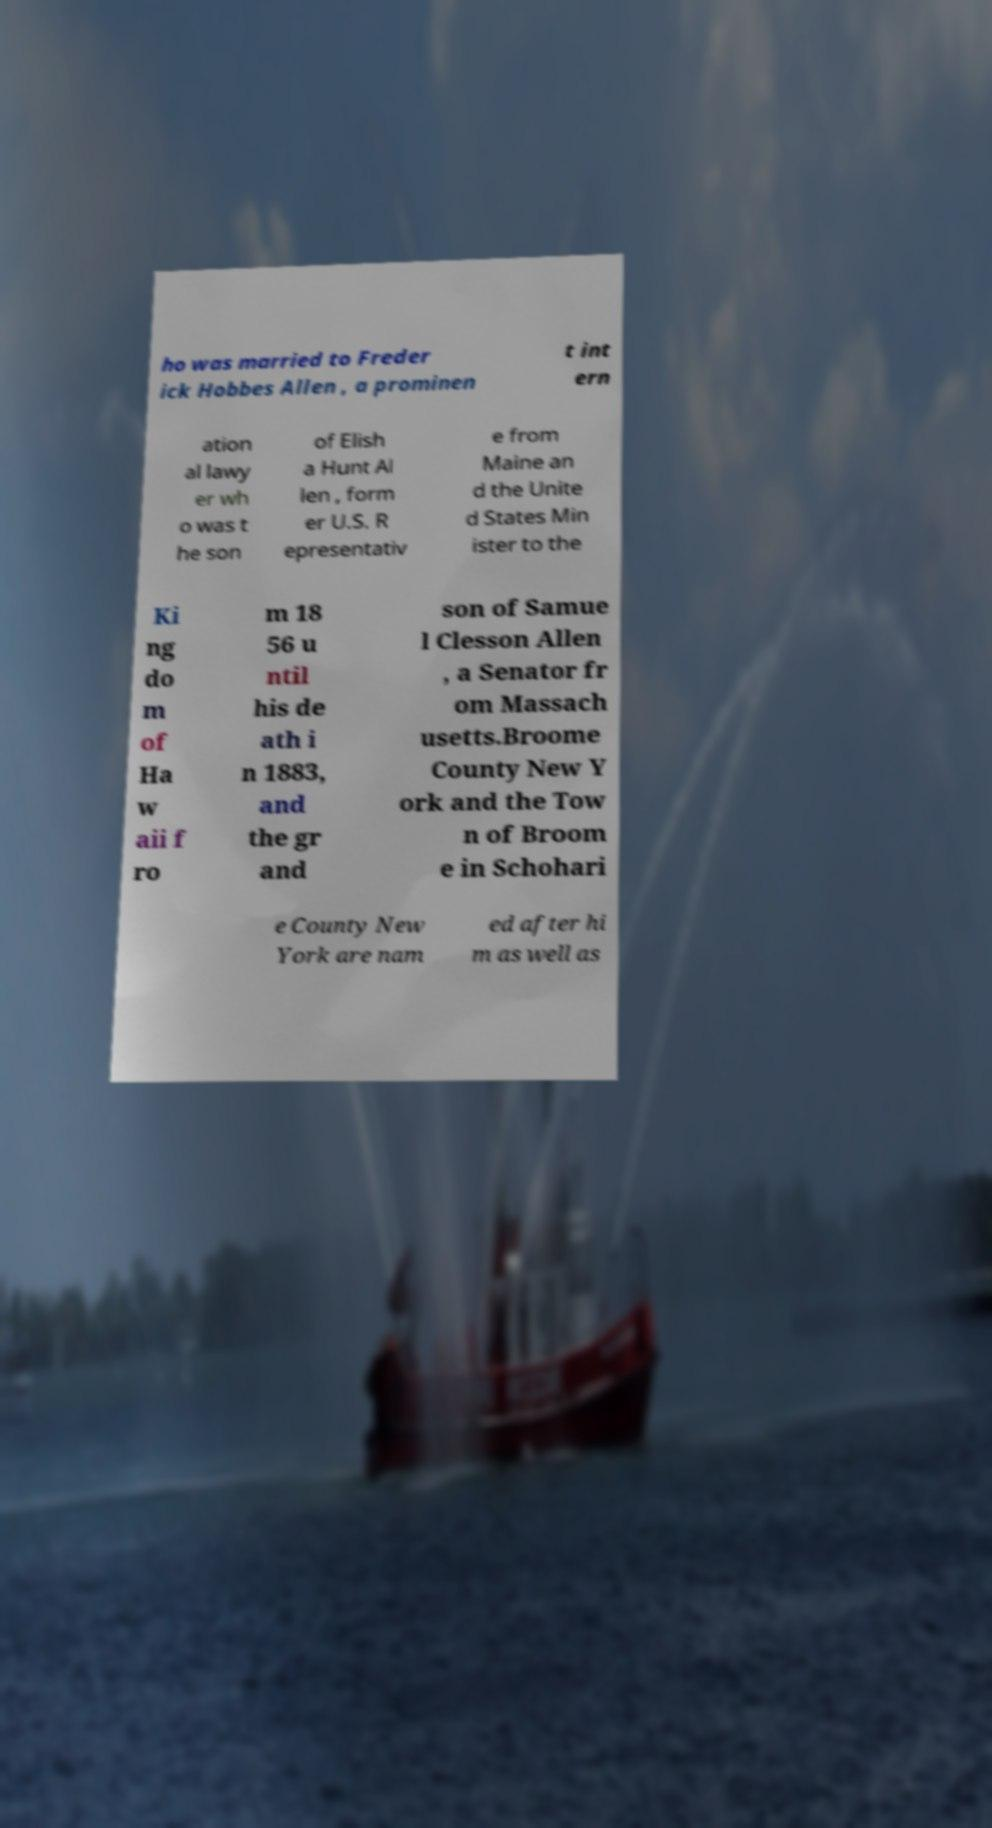Can you accurately transcribe the text from the provided image for me? ho was married to Freder ick Hobbes Allen , a prominen t int ern ation al lawy er wh o was t he son of Elish a Hunt Al len , form er U.S. R epresentativ e from Maine an d the Unite d States Min ister to the Ki ng do m of Ha w aii f ro m 18 56 u ntil his de ath i n 1883, and the gr and son of Samue l Clesson Allen , a Senator fr om Massach usetts.Broome County New Y ork and the Tow n of Broom e in Schohari e County New York are nam ed after hi m as well as 